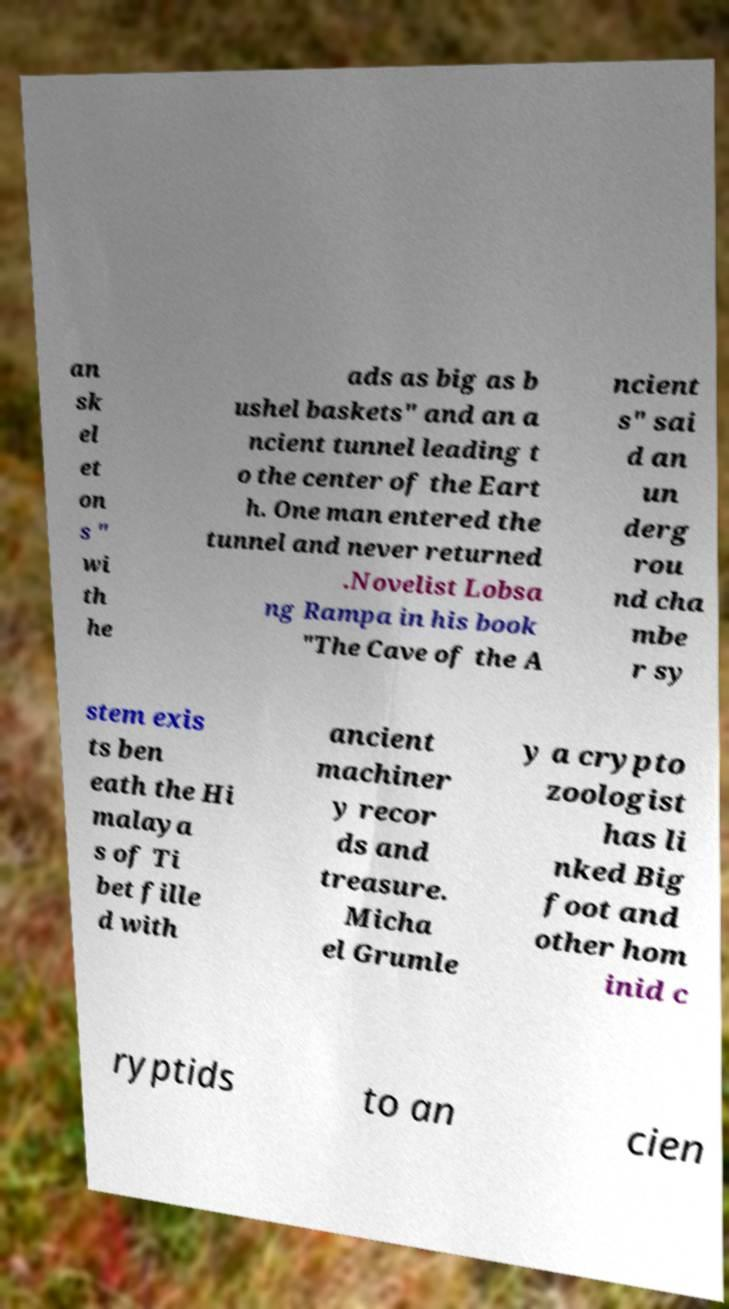Can you read and provide the text displayed in the image?This photo seems to have some interesting text. Can you extract and type it out for me? an sk el et on s " wi th he ads as big as b ushel baskets" and an a ncient tunnel leading t o the center of the Eart h. One man entered the tunnel and never returned .Novelist Lobsa ng Rampa in his book "The Cave of the A ncient s" sai d an un derg rou nd cha mbe r sy stem exis ts ben eath the Hi malaya s of Ti bet fille d with ancient machiner y recor ds and treasure. Micha el Grumle y a crypto zoologist has li nked Big foot and other hom inid c ryptids to an cien 